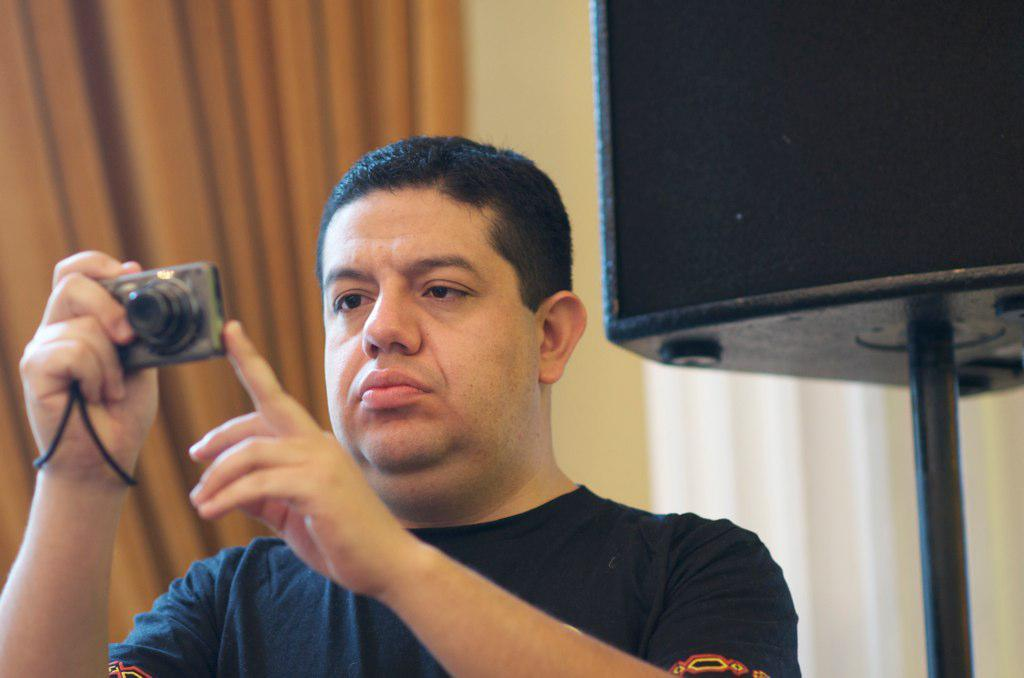Who is the main subject in the image? There is a man in the image. What is the man holding in the image? The man is holding a camera. What is the man doing with the camera? The man is looking at the camera. What other objects can be seen in the image? There are speakers and curtains visible in the image. What type of background is present in the image? There is a wall in the image. What type of cream can be seen on the man's face in the image? There is no cream visible on the man's face in the image. What is the man's view of the landscape in the image? The image does not show a landscape, so it is not possible to determine the man's view of the landscape. 